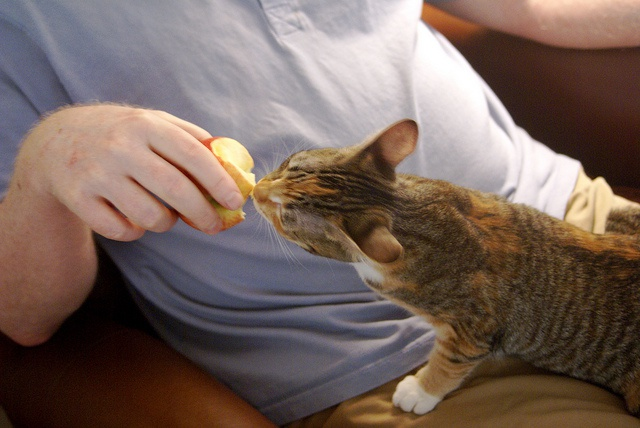Describe the objects in this image and their specific colors. I can see people in gray, darkgray, and lightgray tones, cat in gray, black, and maroon tones, chair in gray, black, maroon, and brown tones, and apple in gray, khaki, orange, brown, and lightyellow tones in this image. 